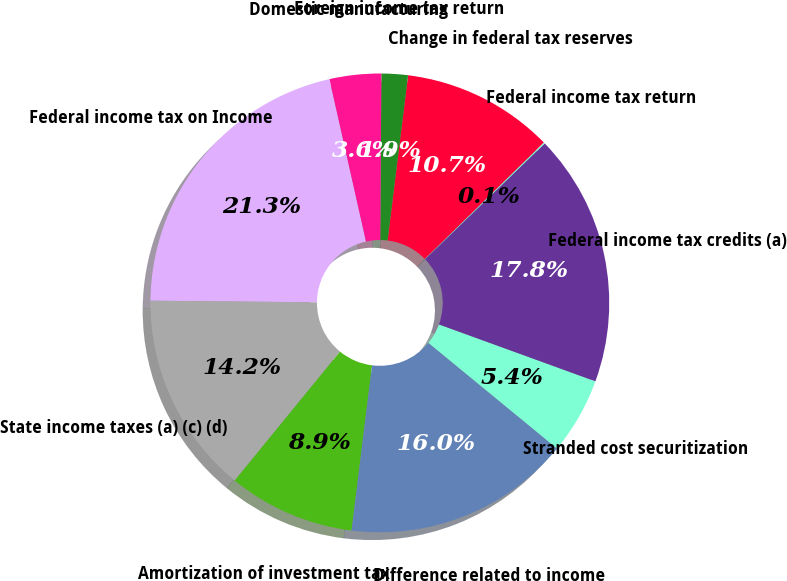<chart> <loc_0><loc_0><loc_500><loc_500><pie_chart><fcel>Federal income tax on Income<fcel>State income taxes (a) (c) (d)<fcel>Amortization of investment tax<fcel>Difference related to income<fcel>Stranded cost securitization<fcel>Federal income tax credits (a)<fcel>Federal income tax return<fcel>Change in federal tax reserves<fcel>Foreign income tax return<fcel>Domestic manufacturing<nl><fcel>21.33%<fcel>14.25%<fcel>8.94%<fcel>16.02%<fcel>5.4%<fcel>17.79%<fcel>0.09%<fcel>10.71%<fcel>1.86%<fcel>3.63%<nl></chart> 